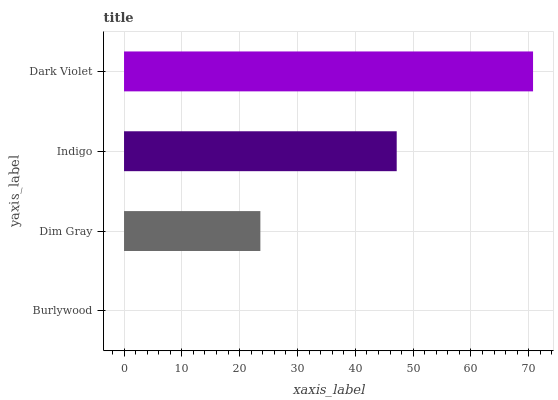Is Burlywood the minimum?
Answer yes or no. Yes. Is Dark Violet the maximum?
Answer yes or no. Yes. Is Dim Gray the minimum?
Answer yes or no. No. Is Dim Gray the maximum?
Answer yes or no. No. Is Dim Gray greater than Burlywood?
Answer yes or no. Yes. Is Burlywood less than Dim Gray?
Answer yes or no. Yes. Is Burlywood greater than Dim Gray?
Answer yes or no. No. Is Dim Gray less than Burlywood?
Answer yes or no. No. Is Indigo the high median?
Answer yes or no. Yes. Is Dim Gray the low median?
Answer yes or no. Yes. Is Burlywood the high median?
Answer yes or no. No. Is Indigo the low median?
Answer yes or no. No. 